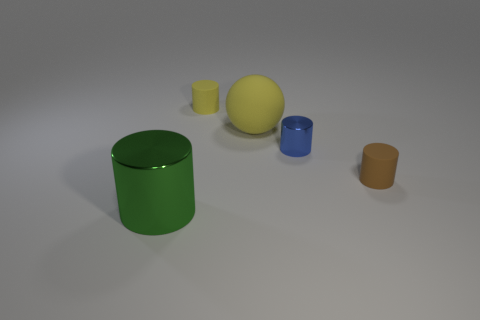There is a rubber thing that is to the left of the tiny blue shiny thing and in front of the small yellow cylinder; what is its shape?
Offer a very short reply. Sphere. There is a ball that is the same material as the small brown object; what size is it?
Provide a succinct answer. Large. Is the number of large cyan rubber balls less than the number of yellow rubber objects?
Your answer should be compact. Yes. There is a object on the left side of the small object that is on the left side of the metal cylinder right of the green thing; what is it made of?
Provide a short and direct response. Metal. Is the cylinder in front of the tiny brown cylinder made of the same material as the large thing that is behind the large green cylinder?
Provide a succinct answer. No. There is a cylinder that is in front of the large yellow matte sphere and behind the tiny brown cylinder; what size is it?
Offer a very short reply. Small. There is a thing that is the same size as the matte ball; what is it made of?
Give a very brief answer. Metal. There is a shiny cylinder that is on the right side of the big green metallic thing that is in front of the big yellow rubber ball; what number of big green cylinders are left of it?
Provide a succinct answer. 1. There is a big thing to the right of the yellow cylinder; is it the same color as the cylinder that is behind the big yellow thing?
Keep it short and to the point. Yes. The tiny thing that is both to the left of the brown matte cylinder and in front of the sphere is what color?
Provide a short and direct response. Blue. 